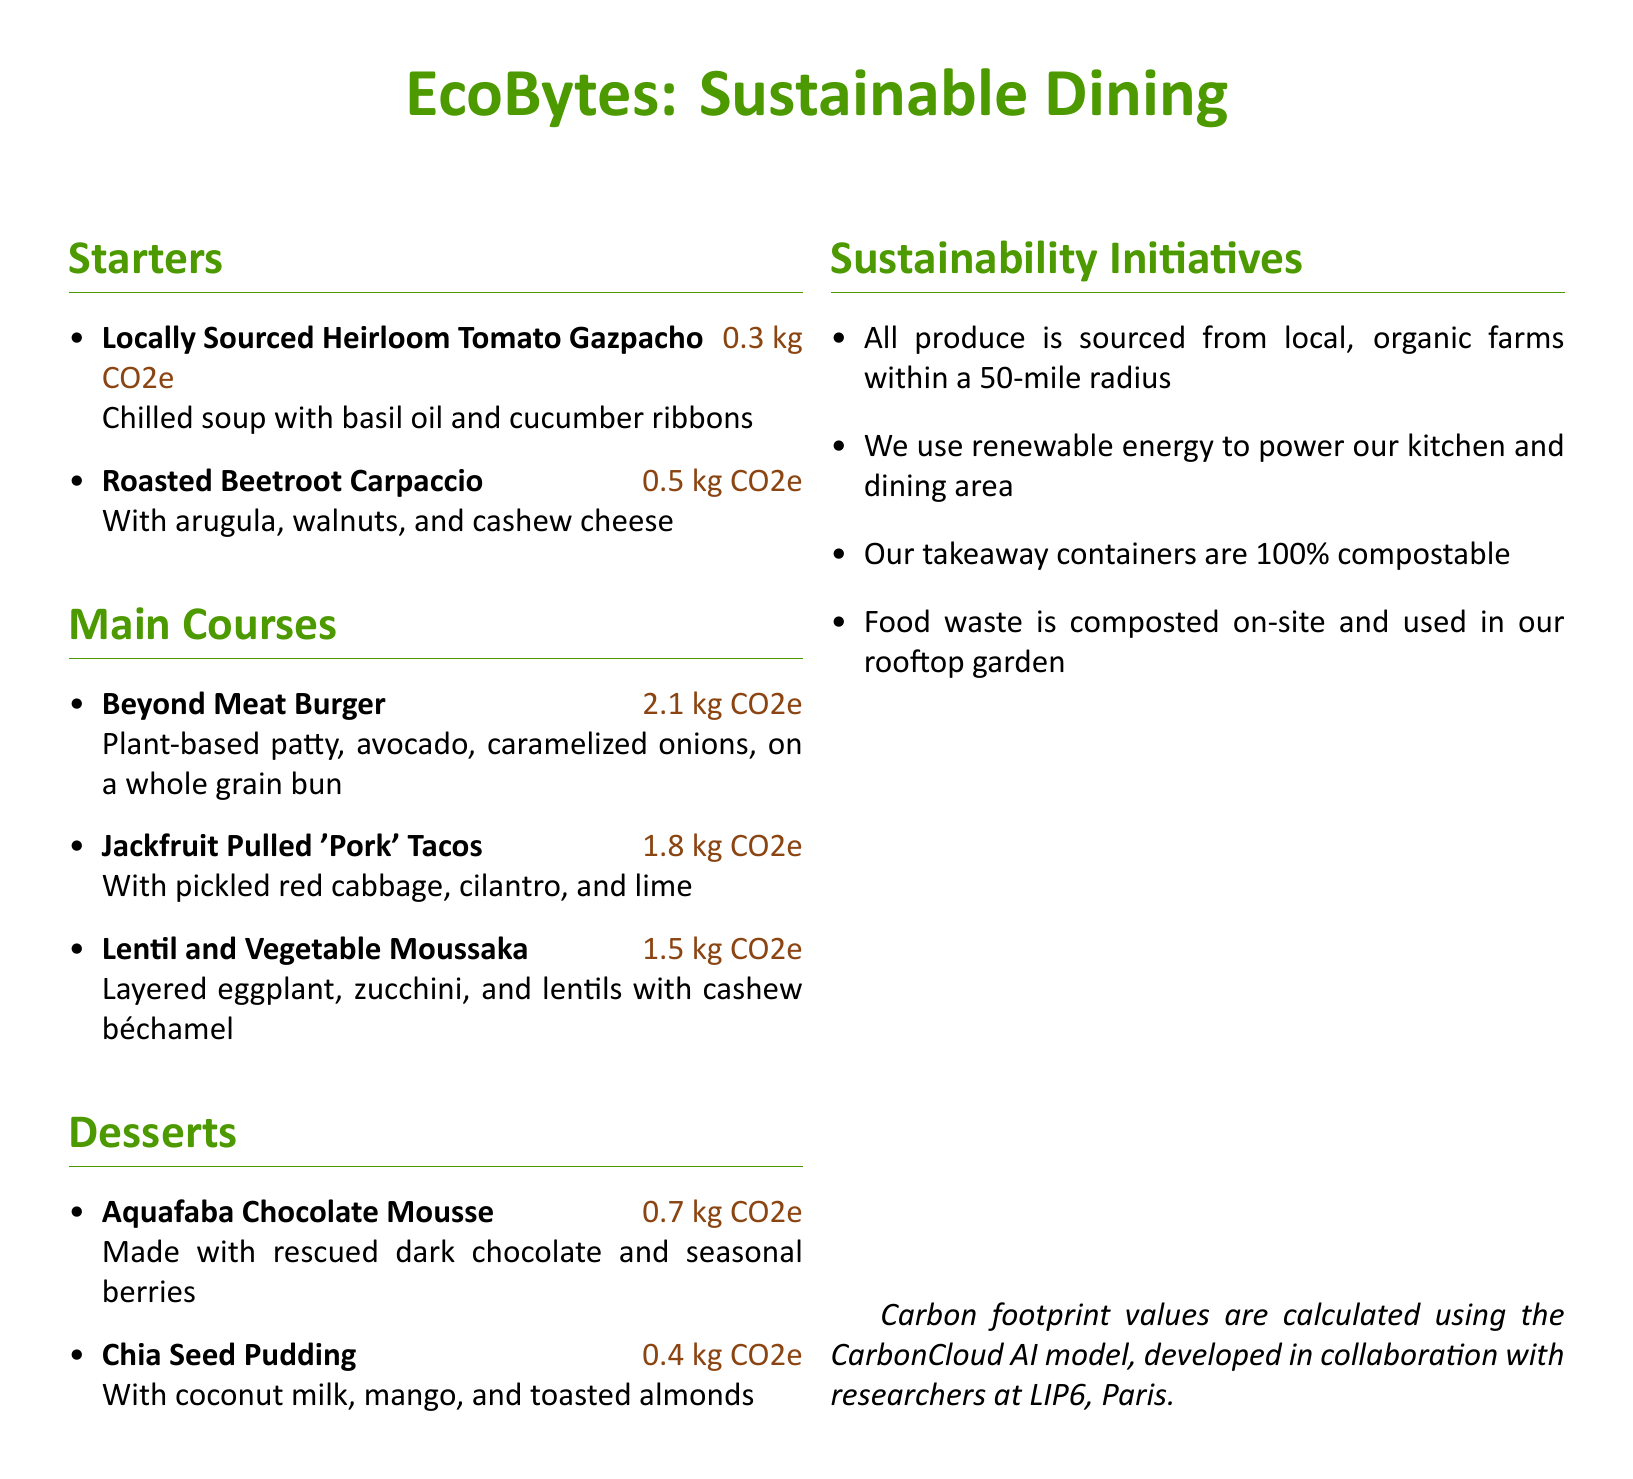what is the carbon footprint of the Roasted Beetroot Carpaccio? The carbon footprint of the Roasted Beetroot Carpaccio is stated next to its name in the document as 0.5 kg CO2e.
Answer: 0.5 kg CO2e how many main courses are listed in the menu? The number of main courses can be counted from the "Main Courses" section in the document, which lists three dishes.
Answer: 3 what is the title of the menu? The title of the menu is prominently displayed at the top of the document, stating "EcoBytes: Sustainable Dining."
Answer: EcoBytes: Sustainable Dining which dessert has the lowest carbon footprint? The dessert with the lowest carbon footprint is indicated by the CO2e value next to each dessert, which shows that Chia Seed Pudding has a footprint of 0.4 kg CO2e.
Answer: Chia Seed Pudding what type of energy does the restaurant use? The document specifies that the restaurant uses renewable energy to power its kitchen and dining area.
Answer: renewable energy how many starters are there on the menu? The number of starters can be found in the "Starters" section of the document, which lists two dishes.
Answer: 2 what ingredient is used in the Aquafaba Chocolate Mousse? The Aquafaba Chocolate Mousse is made with rescued dark chocolate, as mentioned in the description of the dessert.
Answer: rescued dark chocolate which sustainable initiative involves food waste? The document mentions that food waste is composted on-site and used in the rooftop garden, detailing a specific initiative for sustainability.
Answer: composted on-site what is the carbon footprint of the Beyond Meat Burger? The carbon footprint for the Beyond Meat Burger is clearly indicated next to the dish in the menu as 2.1 kg CO2e.
Answer: 2.1 kg CO2e 